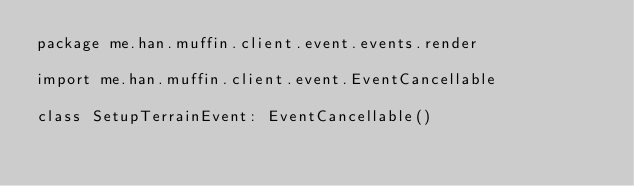<code> <loc_0><loc_0><loc_500><loc_500><_Kotlin_>package me.han.muffin.client.event.events.render

import me.han.muffin.client.event.EventCancellable

class SetupTerrainEvent: EventCancellable()</code> 